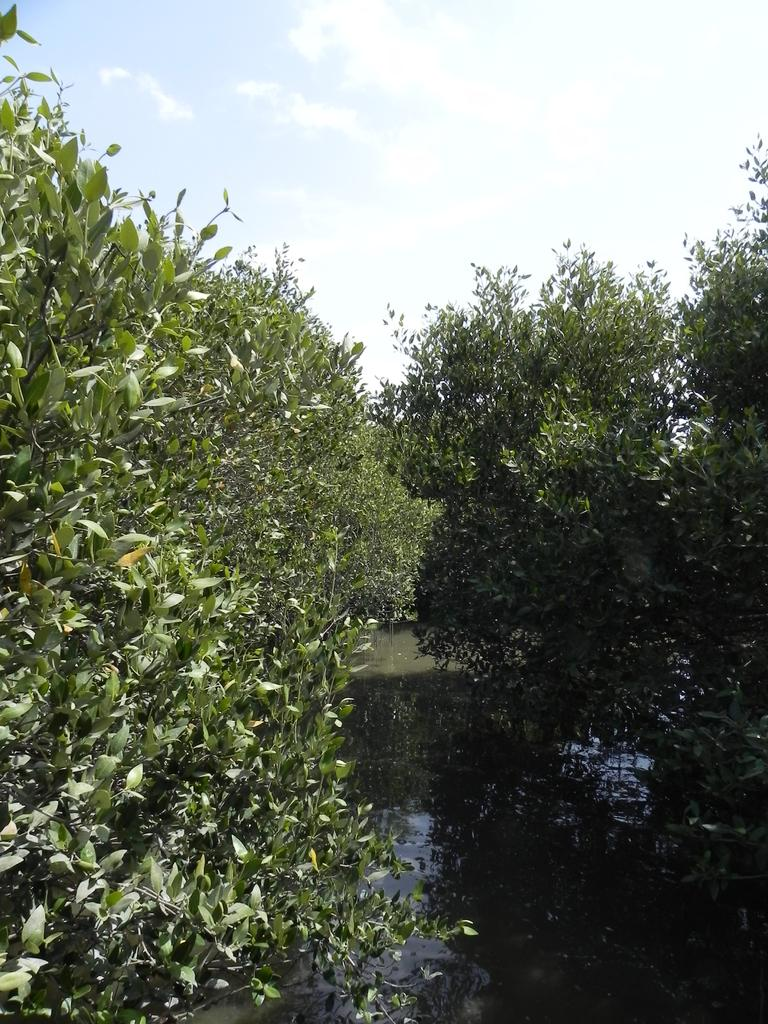What type of body of water is present in the image? There is a small lake in the picture. What natural elements can be seen around the lake? Trees are visible in the picture. What else can be seen in the sky in the image? The sky is visible in the picture. What type of cloth is being used to make popcorn in the image? There is no popcorn or cloth present in the image. Can you describe the seashore visible in the image? There is no seashore visible in the image; it features a small lake surrounded by trees. 